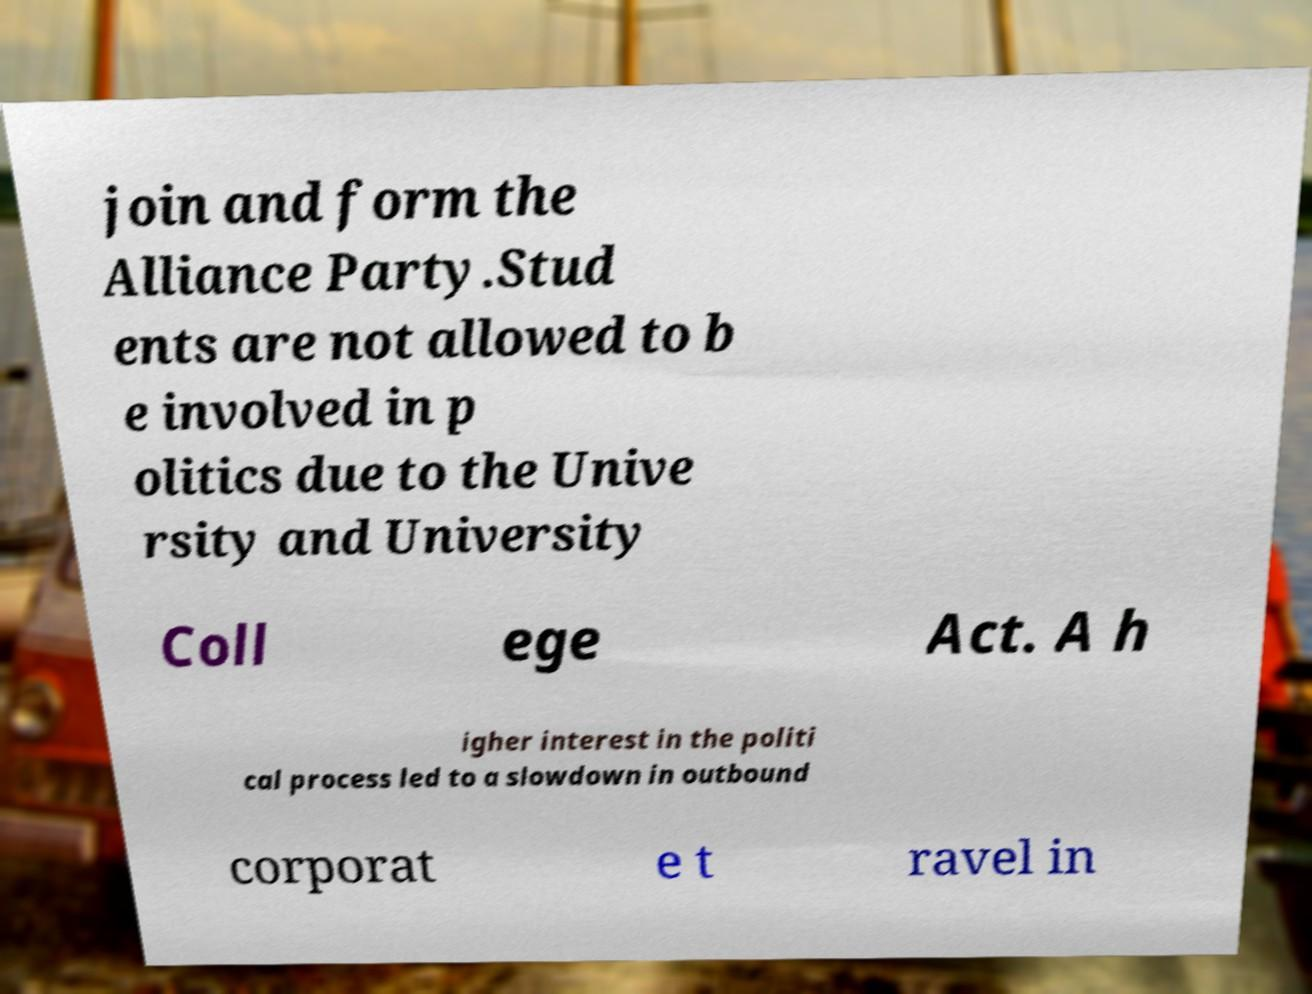Could you extract and type out the text from this image? join and form the Alliance Party.Stud ents are not allowed to b e involved in p olitics due to the Unive rsity and University Coll ege Act. A h igher interest in the politi cal process led to a slowdown in outbound corporat e t ravel in 